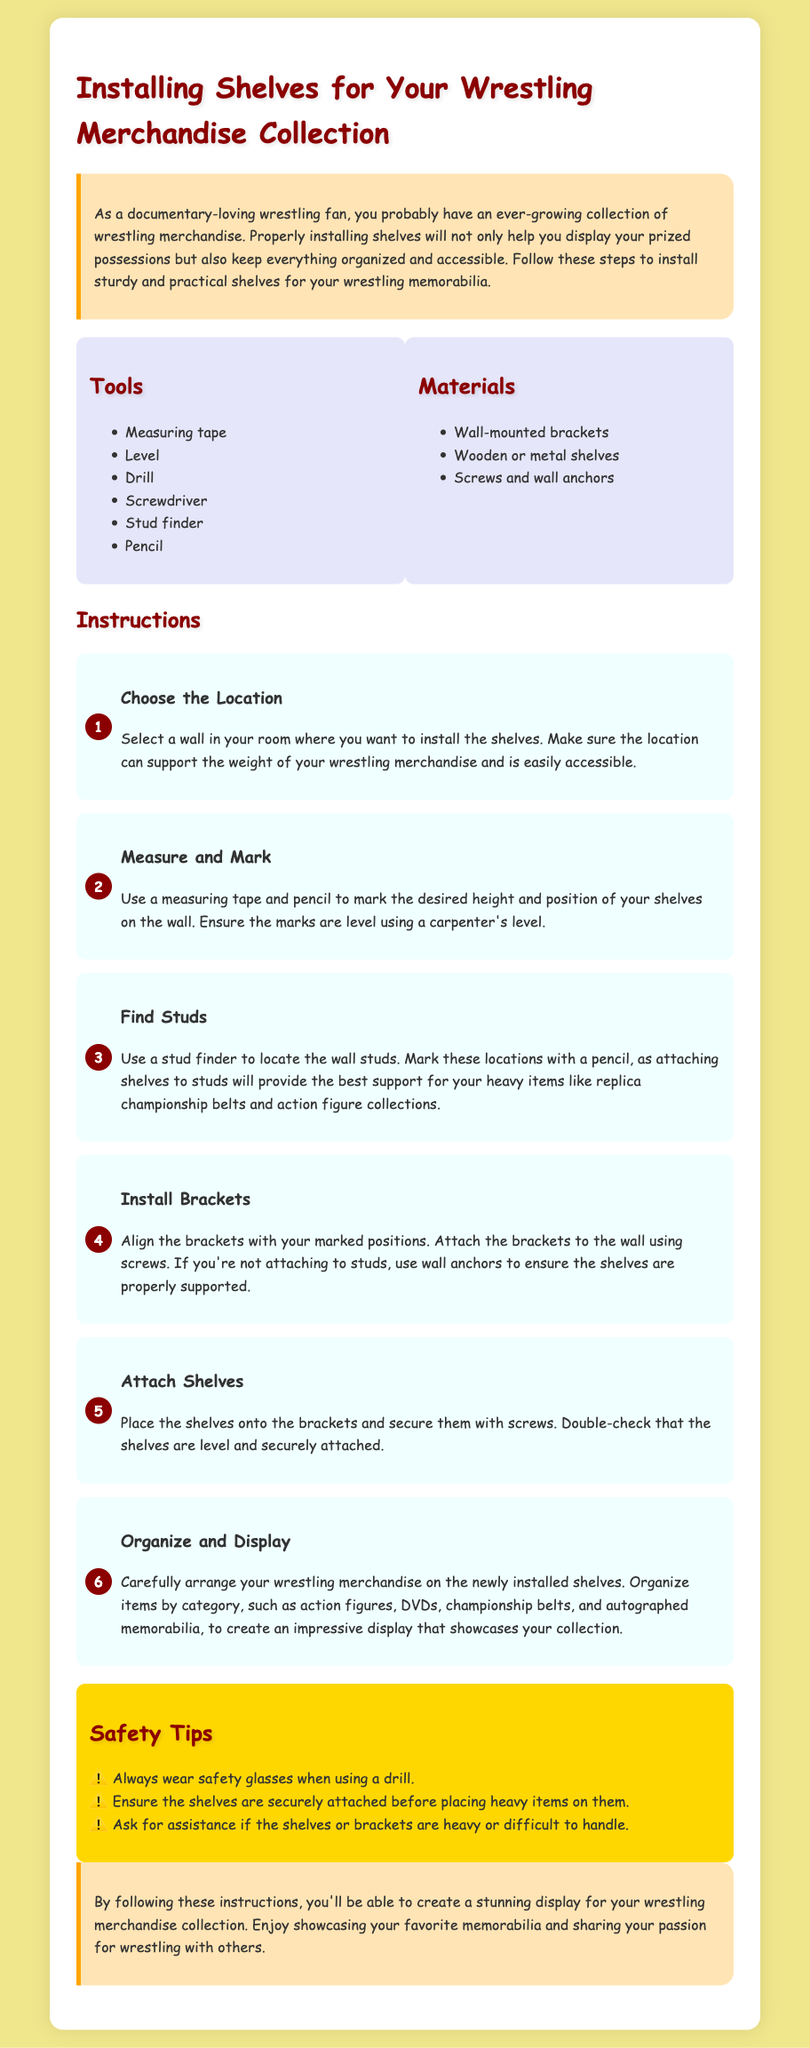What is the title of the document? The title is prominently displayed at the top of the document and is designed to convey the main topic.
Answer: Installing Shelves for Your Wrestling Merchandise Collection How many steps are included in the instructions? The number of steps can be counted in the instructions section of the document.
Answer: Six What tool is used to find studs? This tool is specifically mentioned in the list of tools required for the installation process.
Answer: Stud finder What is used to secure the shelves to the brackets? This information is found in the instructions on how to attach the shelves to the installed brackets.
Answer: Screws What type of glasses should be worn during installation? This safety recommendation is highlighted in the safety tips section of the document.
Answer: Safety glasses Name one type of merchandise suggested for display. This is mentioned in the instructions on how to organize the shelves after installation.
Answer: Action figures What color is the background of the body? The color of the background is specified within the CSS styling of the document.
Answer: Light yellow What is the main purpose of installing the shelves? The main purpose is highlighted in the introduction of the document.
Answer: Display wrestling merchandise 